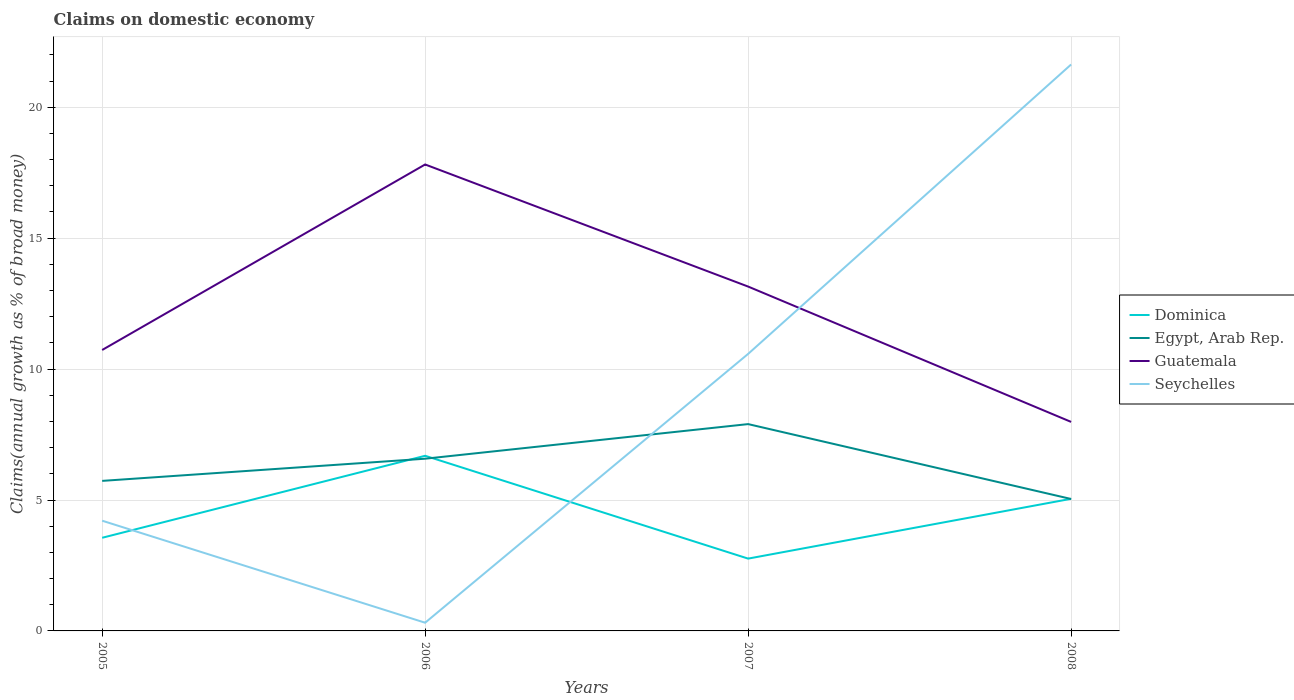Does the line corresponding to Guatemala intersect with the line corresponding to Egypt, Arab Rep.?
Your response must be concise. No. Is the number of lines equal to the number of legend labels?
Offer a terse response. Yes. Across all years, what is the maximum percentage of broad money claimed on domestic economy in Guatemala?
Your answer should be very brief. 7.98. In which year was the percentage of broad money claimed on domestic economy in Guatemala maximum?
Make the answer very short. 2008. What is the total percentage of broad money claimed on domestic economy in Guatemala in the graph?
Ensure brevity in your answer.  4.66. What is the difference between the highest and the second highest percentage of broad money claimed on domestic economy in Egypt, Arab Rep.?
Provide a short and direct response. 2.86. What is the difference between the highest and the lowest percentage of broad money claimed on domestic economy in Dominica?
Ensure brevity in your answer.  2. Is the percentage of broad money claimed on domestic economy in Guatemala strictly greater than the percentage of broad money claimed on domestic economy in Dominica over the years?
Your response must be concise. No. How many years are there in the graph?
Provide a succinct answer. 4. Are the values on the major ticks of Y-axis written in scientific E-notation?
Make the answer very short. No. Does the graph contain grids?
Provide a short and direct response. Yes. How are the legend labels stacked?
Give a very brief answer. Vertical. What is the title of the graph?
Your answer should be compact. Claims on domestic economy. What is the label or title of the Y-axis?
Your answer should be very brief. Claims(annual growth as % of broad money). What is the Claims(annual growth as % of broad money) of Dominica in 2005?
Offer a very short reply. 3.56. What is the Claims(annual growth as % of broad money) of Egypt, Arab Rep. in 2005?
Offer a terse response. 5.73. What is the Claims(annual growth as % of broad money) in Guatemala in 2005?
Make the answer very short. 10.73. What is the Claims(annual growth as % of broad money) of Seychelles in 2005?
Your answer should be very brief. 4.21. What is the Claims(annual growth as % of broad money) in Dominica in 2006?
Give a very brief answer. 6.69. What is the Claims(annual growth as % of broad money) of Egypt, Arab Rep. in 2006?
Offer a very short reply. 6.58. What is the Claims(annual growth as % of broad money) in Guatemala in 2006?
Provide a short and direct response. 17.81. What is the Claims(annual growth as % of broad money) of Seychelles in 2006?
Your answer should be compact. 0.31. What is the Claims(annual growth as % of broad money) of Dominica in 2007?
Provide a succinct answer. 2.76. What is the Claims(annual growth as % of broad money) of Egypt, Arab Rep. in 2007?
Your answer should be compact. 7.9. What is the Claims(annual growth as % of broad money) of Guatemala in 2007?
Your answer should be very brief. 13.15. What is the Claims(annual growth as % of broad money) of Seychelles in 2007?
Give a very brief answer. 10.58. What is the Claims(annual growth as % of broad money) of Dominica in 2008?
Your response must be concise. 5.05. What is the Claims(annual growth as % of broad money) of Egypt, Arab Rep. in 2008?
Ensure brevity in your answer.  5.04. What is the Claims(annual growth as % of broad money) of Guatemala in 2008?
Ensure brevity in your answer.  7.98. What is the Claims(annual growth as % of broad money) in Seychelles in 2008?
Give a very brief answer. 21.63. Across all years, what is the maximum Claims(annual growth as % of broad money) in Dominica?
Your answer should be very brief. 6.69. Across all years, what is the maximum Claims(annual growth as % of broad money) in Egypt, Arab Rep.?
Provide a short and direct response. 7.9. Across all years, what is the maximum Claims(annual growth as % of broad money) in Guatemala?
Offer a terse response. 17.81. Across all years, what is the maximum Claims(annual growth as % of broad money) of Seychelles?
Keep it short and to the point. 21.63. Across all years, what is the minimum Claims(annual growth as % of broad money) in Dominica?
Your answer should be compact. 2.76. Across all years, what is the minimum Claims(annual growth as % of broad money) of Egypt, Arab Rep.?
Your response must be concise. 5.04. Across all years, what is the minimum Claims(annual growth as % of broad money) of Guatemala?
Your answer should be compact. 7.98. Across all years, what is the minimum Claims(annual growth as % of broad money) of Seychelles?
Keep it short and to the point. 0.31. What is the total Claims(annual growth as % of broad money) in Dominica in the graph?
Make the answer very short. 18.05. What is the total Claims(annual growth as % of broad money) in Egypt, Arab Rep. in the graph?
Offer a very short reply. 25.25. What is the total Claims(annual growth as % of broad money) of Guatemala in the graph?
Make the answer very short. 49.68. What is the total Claims(annual growth as % of broad money) in Seychelles in the graph?
Provide a short and direct response. 36.74. What is the difference between the Claims(annual growth as % of broad money) in Dominica in 2005 and that in 2006?
Ensure brevity in your answer.  -3.13. What is the difference between the Claims(annual growth as % of broad money) of Egypt, Arab Rep. in 2005 and that in 2006?
Ensure brevity in your answer.  -0.85. What is the difference between the Claims(annual growth as % of broad money) in Guatemala in 2005 and that in 2006?
Keep it short and to the point. -7.08. What is the difference between the Claims(annual growth as % of broad money) in Seychelles in 2005 and that in 2006?
Ensure brevity in your answer.  3.9. What is the difference between the Claims(annual growth as % of broad money) of Dominica in 2005 and that in 2007?
Make the answer very short. 0.8. What is the difference between the Claims(annual growth as % of broad money) in Egypt, Arab Rep. in 2005 and that in 2007?
Provide a short and direct response. -2.17. What is the difference between the Claims(annual growth as % of broad money) of Guatemala in 2005 and that in 2007?
Your response must be concise. -2.42. What is the difference between the Claims(annual growth as % of broad money) in Seychelles in 2005 and that in 2007?
Your answer should be compact. -6.37. What is the difference between the Claims(annual growth as % of broad money) of Dominica in 2005 and that in 2008?
Provide a short and direct response. -1.49. What is the difference between the Claims(annual growth as % of broad money) in Egypt, Arab Rep. in 2005 and that in 2008?
Keep it short and to the point. 0.69. What is the difference between the Claims(annual growth as % of broad money) in Guatemala in 2005 and that in 2008?
Your response must be concise. 2.75. What is the difference between the Claims(annual growth as % of broad money) of Seychelles in 2005 and that in 2008?
Keep it short and to the point. -17.42. What is the difference between the Claims(annual growth as % of broad money) of Dominica in 2006 and that in 2007?
Your response must be concise. 3.93. What is the difference between the Claims(annual growth as % of broad money) in Egypt, Arab Rep. in 2006 and that in 2007?
Offer a very short reply. -1.32. What is the difference between the Claims(annual growth as % of broad money) in Guatemala in 2006 and that in 2007?
Keep it short and to the point. 4.66. What is the difference between the Claims(annual growth as % of broad money) in Seychelles in 2006 and that in 2007?
Ensure brevity in your answer.  -10.27. What is the difference between the Claims(annual growth as % of broad money) in Dominica in 2006 and that in 2008?
Provide a short and direct response. 1.64. What is the difference between the Claims(annual growth as % of broad money) in Egypt, Arab Rep. in 2006 and that in 2008?
Your answer should be compact. 1.54. What is the difference between the Claims(annual growth as % of broad money) of Guatemala in 2006 and that in 2008?
Your answer should be compact. 9.83. What is the difference between the Claims(annual growth as % of broad money) in Seychelles in 2006 and that in 2008?
Offer a terse response. -21.32. What is the difference between the Claims(annual growth as % of broad money) of Dominica in 2007 and that in 2008?
Your answer should be very brief. -2.28. What is the difference between the Claims(annual growth as % of broad money) of Egypt, Arab Rep. in 2007 and that in 2008?
Ensure brevity in your answer.  2.86. What is the difference between the Claims(annual growth as % of broad money) of Guatemala in 2007 and that in 2008?
Ensure brevity in your answer.  5.17. What is the difference between the Claims(annual growth as % of broad money) in Seychelles in 2007 and that in 2008?
Your answer should be very brief. -11.05. What is the difference between the Claims(annual growth as % of broad money) of Dominica in 2005 and the Claims(annual growth as % of broad money) of Egypt, Arab Rep. in 2006?
Provide a short and direct response. -3.02. What is the difference between the Claims(annual growth as % of broad money) of Dominica in 2005 and the Claims(annual growth as % of broad money) of Guatemala in 2006?
Make the answer very short. -14.26. What is the difference between the Claims(annual growth as % of broad money) in Dominica in 2005 and the Claims(annual growth as % of broad money) in Seychelles in 2006?
Provide a short and direct response. 3.24. What is the difference between the Claims(annual growth as % of broad money) of Egypt, Arab Rep. in 2005 and the Claims(annual growth as % of broad money) of Guatemala in 2006?
Your answer should be very brief. -12.08. What is the difference between the Claims(annual growth as % of broad money) in Egypt, Arab Rep. in 2005 and the Claims(annual growth as % of broad money) in Seychelles in 2006?
Give a very brief answer. 5.42. What is the difference between the Claims(annual growth as % of broad money) in Guatemala in 2005 and the Claims(annual growth as % of broad money) in Seychelles in 2006?
Offer a very short reply. 10.42. What is the difference between the Claims(annual growth as % of broad money) in Dominica in 2005 and the Claims(annual growth as % of broad money) in Egypt, Arab Rep. in 2007?
Keep it short and to the point. -4.34. What is the difference between the Claims(annual growth as % of broad money) in Dominica in 2005 and the Claims(annual growth as % of broad money) in Guatemala in 2007?
Keep it short and to the point. -9.59. What is the difference between the Claims(annual growth as % of broad money) in Dominica in 2005 and the Claims(annual growth as % of broad money) in Seychelles in 2007?
Your answer should be very brief. -7.02. What is the difference between the Claims(annual growth as % of broad money) in Egypt, Arab Rep. in 2005 and the Claims(annual growth as % of broad money) in Guatemala in 2007?
Make the answer very short. -7.42. What is the difference between the Claims(annual growth as % of broad money) of Egypt, Arab Rep. in 2005 and the Claims(annual growth as % of broad money) of Seychelles in 2007?
Your answer should be very brief. -4.85. What is the difference between the Claims(annual growth as % of broad money) in Guatemala in 2005 and the Claims(annual growth as % of broad money) in Seychelles in 2007?
Keep it short and to the point. 0.15. What is the difference between the Claims(annual growth as % of broad money) in Dominica in 2005 and the Claims(annual growth as % of broad money) in Egypt, Arab Rep. in 2008?
Your answer should be very brief. -1.48. What is the difference between the Claims(annual growth as % of broad money) of Dominica in 2005 and the Claims(annual growth as % of broad money) of Guatemala in 2008?
Ensure brevity in your answer.  -4.43. What is the difference between the Claims(annual growth as % of broad money) of Dominica in 2005 and the Claims(annual growth as % of broad money) of Seychelles in 2008?
Provide a short and direct response. -18.08. What is the difference between the Claims(annual growth as % of broad money) of Egypt, Arab Rep. in 2005 and the Claims(annual growth as % of broad money) of Guatemala in 2008?
Keep it short and to the point. -2.25. What is the difference between the Claims(annual growth as % of broad money) of Egypt, Arab Rep. in 2005 and the Claims(annual growth as % of broad money) of Seychelles in 2008?
Ensure brevity in your answer.  -15.9. What is the difference between the Claims(annual growth as % of broad money) in Guatemala in 2005 and the Claims(annual growth as % of broad money) in Seychelles in 2008?
Keep it short and to the point. -10.9. What is the difference between the Claims(annual growth as % of broad money) of Dominica in 2006 and the Claims(annual growth as % of broad money) of Egypt, Arab Rep. in 2007?
Your answer should be compact. -1.21. What is the difference between the Claims(annual growth as % of broad money) of Dominica in 2006 and the Claims(annual growth as % of broad money) of Guatemala in 2007?
Provide a succinct answer. -6.46. What is the difference between the Claims(annual growth as % of broad money) of Dominica in 2006 and the Claims(annual growth as % of broad money) of Seychelles in 2007?
Make the answer very short. -3.89. What is the difference between the Claims(annual growth as % of broad money) of Egypt, Arab Rep. in 2006 and the Claims(annual growth as % of broad money) of Guatemala in 2007?
Provide a succinct answer. -6.57. What is the difference between the Claims(annual growth as % of broad money) in Egypt, Arab Rep. in 2006 and the Claims(annual growth as % of broad money) in Seychelles in 2007?
Offer a terse response. -4. What is the difference between the Claims(annual growth as % of broad money) of Guatemala in 2006 and the Claims(annual growth as % of broad money) of Seychelles in 2007?
Your response must be concise. 7.23. What is the difference between the Claims(annual growth as % of broad money) in Dominica in 2006 and the Claims(annual growth as % of broad money) in Egypt, Arab Rep. in 2008?
Ensure brevity in your answer.  1.65. What is the difference between the Claims(annual growth as % of broad money) in Dominica in 2006 and the Claims(annual growth as % of broad money) in Guatemala in 2008?
Offer a very short reply. -1.29. What is the difference between the Claims(annual growth as % of broad money) of Dominica in 2006 and the Claims(annual growth as % of broad money) of Seychelles in 2008?
Provide a short and direct response. -14.94. What is the difference between the Claims(annual growth as % of broad money) in Egypt, Arab Rep. in 2006 and the Claims(annual growth as % of broad money) in Guatemala in 2008?
Keep it short and to the point. -1.41. What is the difference between the Claims(annual growth as % of broad money) of Egypt, Arab Rep. in 2006 and the Claims(annual growth as % of broad money) of Seychelles in 2008?
Keep it short and to the point. -15.06. What is the difference between the Claims(annual growth as % of broad money) in Guatemala in 2006 and the Claims(annual growth as % of broad money) in Seychelles in 2008?
Keep it short and to the point. -3.82. What is the difference between the Claims(annual growth as % of broad money) in Dominica in 2007 and the Claims(annual growth as % of broad money) in Egypt, Arab Rep. in 2008?
Your answer should be very brief. -2.28. What is the difference between the Claims(annual growth as % of broad money) in Dominica in 2007 and the Claims(annual growth as % of broad money) in Guatemala in 2008?
Ensure brevity in your answer.  -5.22. What is the difference between the Claims(annual growth as % of broad money) in Dominica in 2007 and the Claims(annual growth as % of broad money) in Seychelles in 2008?
Provide a succinct answer. -18.87. What is the difference between the Claims(annual growth as % of broad money) of Egypt, Arab Rep. in 2007 and the Claims(annual growth as % of broad money) of Guatemala in 2008?
Make the answer very short. -0.08. What is the difference between the Claims(annual growth as % of broad money) in Egypt, Arab Rep. in 2007 and the Claims(annual growth as % of broad money) in Seychelles in 2008?
Your answer should be compact. -13.73. What is the difference between the Claims(annual growth as % of broad money) of Guatemala in 2007 and the Claims(annual growth as % of broad money) of Seychelles in 2008?
Offer a terse response. -8.48. What is the average Claims(annual growth as % of broad money) in Dominica per year?
Provide a short and direct response. 4.51. What is the average Claims(annual growth as % of broad money) of Egypt, Arab Rep. per year?
Your answer should be very brief. 6.31. What is the average Claims(annual growth as % of broad money) in Guatemala per year?
Offer a terse response. 12.42. What is the average Claims(annual growth as % of broad money) of Seychelles per year?
Give a very brief answer. 9.18. In the year 2005, what is the difference between the Claims(annual growth as % of broad money) in Dominica and Claims(annual growth as % of broad money) in Egypt, Arab Rep.?
Your answer should be very brief. -2.17. In the year 2005, what is the difference between the Claims(annual growth as % of broad money) of Dominica and Claims(annual growth as % of broad money) of Guatemala?
Offer a very short reply. -7.17. In the year 2005, what is the difference between the Claims(annual growth as % of broad money) of Dominica and Claims(annual growth as % of broad money) of Seychelles?
Make the answer very short. -0.65. In the year 2005, what is the difference between the Claims(annual growth as % of broad money) in Egypt, Arab Rep. and Claims(annual growth as % of broad money) in Guatemala?
Give a very brief answer. -5. In the year 2005, what is the difference between the Claims(annual growth as % of broad money) of Egypt, Arab Rep. and Claims(annual growth as % of broad money) of Seychelles?
Your response must be concise. 1.52. In the year 2005, what is the difference between the Claims(annual growth as % of broad money) of Guatemala and Claims(annual growth as % of broad money) of Seychelles?
Provide a short and direct response. 6.52. In the year 2006, what is the difference between the Claims(annual growth as % of broad money) in Dominica and Claims(annual growth as % of broad money) in Egypt, Arab Rep.?
Ensure brevity in your answer.  0.11. In the year 2006, what is the difference between the Claims(annual growth as % of broad money) of Dominica and Claims(annual growth as % of broad money) of Guatemala?
Provide a short and direct response. -11.13. In the year 2006, what is the difference between the Claims(annual growth as % of broad money) of Dominica and Claims(annual growth as % of broad money) of Seychelles?
Your answer should be compact. 6.38. In the year 2006, what is the difference between the Claims(annual growth as % of broad money) of Egypt, Arab Rep. and Claims(annual growth as % of broad money) of Guatemala?
Your response must be concise. -11.24. In the year 2006, what is the difference between the Claims(annual growth as % of broad money) in Egypt, Arab Rep. and Claims(annual growth as % of broad money) in Seychelles?
Your answer should be compact. 6.26. In the year 2006, what is the difference between the Claims(annual growth as % of broad money) in Guatemala and Claims(annual growth as % of broad money) in Seychelles?
Provide a short and direct response. 17.5. In the year 2007, what is the difference between the Claims(annual growth as % of broad money) in Dominica and Claims(annual growth as % of broad money) in Egypt, Arab Rep.?
Keep it short and to the point. -5.14. In the year 2007, what is the difference between the Claims(annual growth as % of broad money) in Dominica and Claims(annual growth as % of broad money) in Guatemala?
Make the answer very short. -10.39. In the year 2007, what is the difference between the Claims(annual growth as % of broad money) of Dominica and Claims(annual growth as % of broad money) of Seychelles?
Provide a succinct answer. -7.82. In the year 2007, what is the difference between the Claims(annual growth as % of broad money) in Egypt, Arab Rep. and Claims(annual growth as % of broad money) in Guatemala?
Provide a succinct answer. -5.25. In the year 2007, what is the difference between the Claims(annual growth as % of broad money) of Egypt, Arab Rep. and Claims(annual growth as % of broad money) of Seychelles?
Your answer should be compact. -2.68. In the year 2007, what is the difference between the Claims(annual growth as % of broad money) in Guatemala and Claims(annual growth as % of broad money) in Seychelles?
Provide a short and direct response. 2.57. In the year 2008, what is the difference between the Claims(annual growth as % of broad money) of Dominica and Claims(annual growth as % of broad money) of Egypt, Arab Rep.?
Keep it short and to the point. 0.01. In the year 2008, what is the difference between the Claims(annual growth as % of broad money) of Dominica and Claims(annual growth as % of broad money) of Guatemala?
Your answer should be very brief. -2.94. In the year 2008, what is the difference between the Claims(annual growth as % of broad money) of Dominica and Claims(annual growth as % of broad money) of Seychelles?
Make the answer very short. -16.59. In the year 2008, what is the difference between the Claims(annual growth as % of broad money) of Egypt, Arab Rep. and Claims(annual growth as % of broad money) of Guatemala?
Your response must be concise. -2.94. In the year 2008, what is the difference between the Claims(annual growth as % of broad money) of Egypt, Arab Rep. and Claims(annual growth as % of broad money) of Seychelles?
Make the answer very short. -16.59. In the year 2008, what is the difference between the Claims(annual growth as % of broad money) of Guatemala and Claims(annual growth as % of broad money) of Seychelles?
Your answer should be very brief. -13.65. What is the ratio of the Claims(annual growth as % of broad money) of Dominica in 2005 to that in 2006?
Offer a terse response. 0.53. What is the ratio of the Claims(annual growth as % of broad money) in Egypt, Arab Rep. in 2005 to that in 2006?
Keep it short and to the point. 0.87. What is the ratio of the Claims(annual growth as % of broad money) of Guatemala in 2005 to that in 2006?
Your answer should be very brief. 0.6. What is the ratio of the Claims(annual growth as % of broad money) in Seychelles in 2005 to that in 2006?
Your response must be concise. 13.43. What is the ratio of the Claims(annual growth as % of broad money) of Dominica in 2005 to that in 2007?
Ensure brevity in your answer.  1.29. What is the ratio of the Claims(annual growth as % of broad money) of Egypt, Arab Rep. in 2005 to that in 2007?
Ensure brevity in your answer.  0.73. What is the ratio of the Claims(annual growth as % of broad money) of Guatemala in 2005 to that in 2007?
Offer a very short reply. 0.82. What is the ratio of the Claims(annual growth as % of broad money) in Seychelles in 2005 to that in 2007?
Offer a terse response. 0.4. What is the ratio of the Claims(annual growth as % of broad money) of Dominica in 2005 to that in 2008?
Offer a very short reply. 0.7. What is the ratio of the Claims(annual growth as % of broad money) in Egypt, Arab Rep. in 2005 to that in 2008?
Your response must be concise. 1.14. What is the ratio of the Claims(annual growth as % of broad money) in Guatemala in 2005 to that in 2008?
Your response must be concise. 1.34. What is the ratio of the Claims(annual growth as % of broad money) of Seychelles in 2005 to that in 2008?
Make the answer very short. 0.19. What is the ratio of the Claims(annual growth as % of broad money) of Dominica in 2006 to that in 2007?
Your answer should be compact. 2.42. What is the ratio of the Claims(annual growth as % of broad money) of Egypt, Arab Rep. in 2006 to that in 2007?
Offer a very short reply. 0.83. What is the ratio of the Claims(annual growth as % of broad money) in Guatemala in 2006 to that in 2007?
Make the answer very short. 1.35. What is the ratio of the Claims(annual growth as % of broad money) in Seychelles in 2006 to that in 2007?
Ensure brevity in your answer.  0.03. What is the ratio of the Claims(annual growth as % of broad money) of Dominica in 2006 to that in 2008?
Offer a terse response. 1.33. What is the ratio of the Claims(annual growth as % of broad money) of Egypt, Arab Rep. in 2006 to that in 2008?
Your answer should be compact. 1.31. What is the ratio of the Claims(annual growth as % of broad money) of Guatemala in 2006 to that in 2008?
Make the answer very short. 2.23. What is the ratio of the Claims(annual growth as % of broad money) of Seychelles in 2006 to that in 2008?
Your response must be concise. 0.01. What is the ratio of the Claims(annual growth as % of broad money) in Dominica in 2007 to that in 2008?
Give a very brief answer. 0.55. What is the ratio of the Claims(annual growth as % of broad money) of Egypt, Arab Rep. in 2007 to that in 2008?
Your answer should be very brief. 1.57. What is the ratio of the Claims(annual growth as % of broad money) of Guatemala in 2007 to that in 2008?
Keep it short and to the point. 1.65. What is the ratio of the Claims(annual growth as % of broad money) of Seychelles in 2007 to that in 2008?
Give a very brief answer. 0.49. What is the difference between the highest and the second highest Claims(annual growth as % of broad money) of Dominica?
Your answer should be very brief. 1.64. What is the difference between the highest and the second highest Claims(annual growth as % of broad money) of Egypt, Arab Rep.?
Ensure brevity in your answer.  1.32. What is the difference between the highest and the second highest Claims(annual growth as % of broad money) in Guatemala?
Give a very brief answer. 4.66. What is the difference between the highest and the second highest Claims(annual growth as % of broad money) of Seychelles?
Make the answer very short. 11.05. What is the difference between the highest and the lowest Claims(annual growth as % of broad money) of Dominica?
Make the answer very short. 3.93. What is the difference between the highest and the lowest Claims(annual growth as % of broad money) of Egypt, Arab Rep.?
Provide a short and direct response. 2.86. What is the difference between the highest and the lowest Claims(annual growth as % of broad money) in Guatemala?
Provide a succinct answer. 9.83. What is the difference between the highest and the lowest Claims(annual growth as % of broad money) in Seychelles?
Your answer should be very brief. 21.32. 